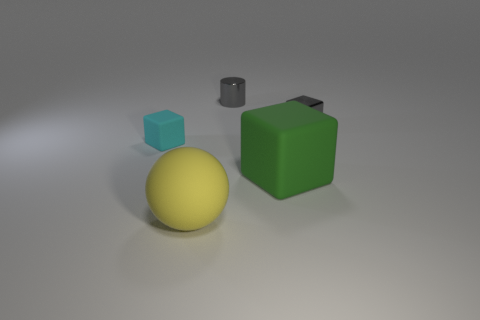Is the color of the shiny block the same as the metallic cylinder?
Your response must be concise. Yes. What material is the thing that is the same color as the metal cylinder?
Keep it short and to the point. Metal. Are there fewer big rubber balls behind the cyan block than small rubber cylinders?
Offer a very short reply. No. There is a tiny metallic object that is right of the gray object that is left of the tiny block that is right of the cyan matte object; what color is it?
Provide a short and direct response. Gray. What number of matte objects are gray blocks or blue cylinders?
Ensure brevity in your answer.  0. Does the metallic cylinder have the same size as the cyan object?
Your response must be concise. Yes. Are there fewer yellow balls behind the large green rubber block than small gray metal things that are in front of the metal cylinder?
Provide a short and direct response. Yes. What is the size of the yellow matte ball?
Give a very brief answer. Large. How many tiny objects are either blue rubber objects or cyan blocks?
Offer a very short reply. 1. There is a matte ball; is its size the same as the matte cube right of the yellow rubber object?
Offer a very short reply. Yes. 